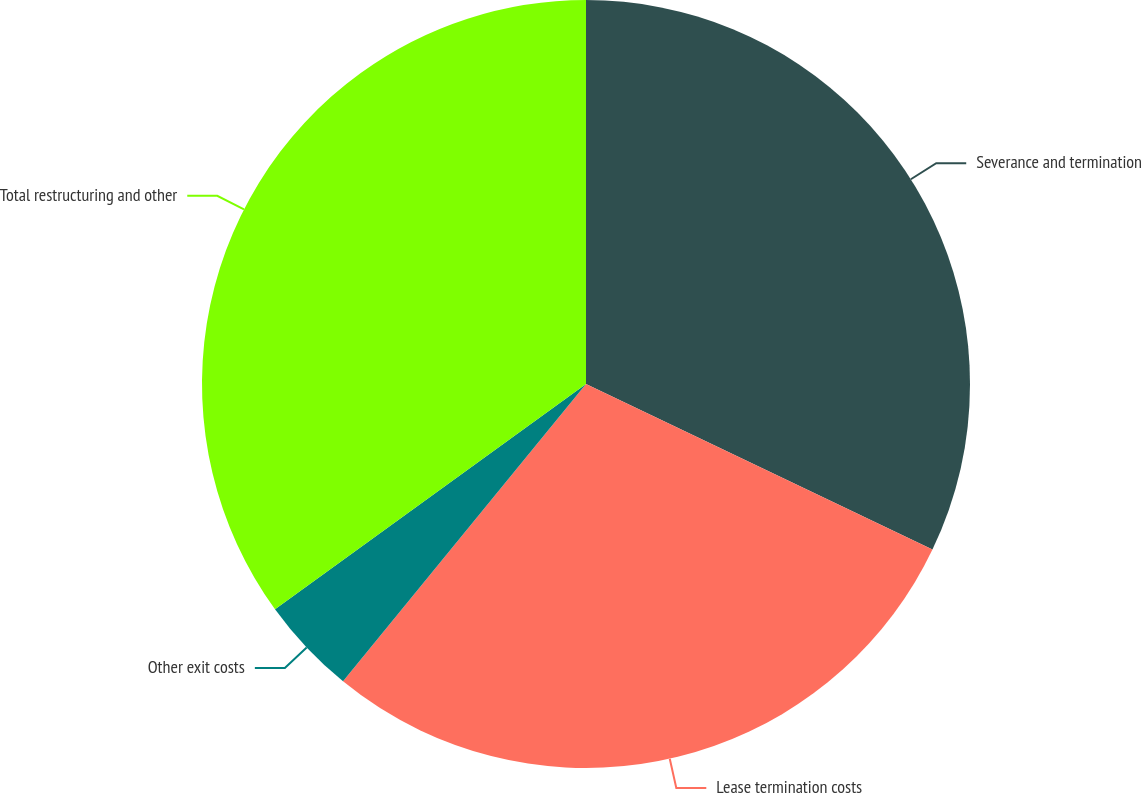Convert chart to OTSL. <chart><loc_0><loc_0><loc_500><loc_500><pie_chart><fcel>Severance and termination<fcel>Lease termination costs<fcel>Other exit costs<fcel>Total restructuring and other<nl><fcel>32.1%<fcel>28.81%<fcel>4.12%<fcel>34.98%<nl></chart> 